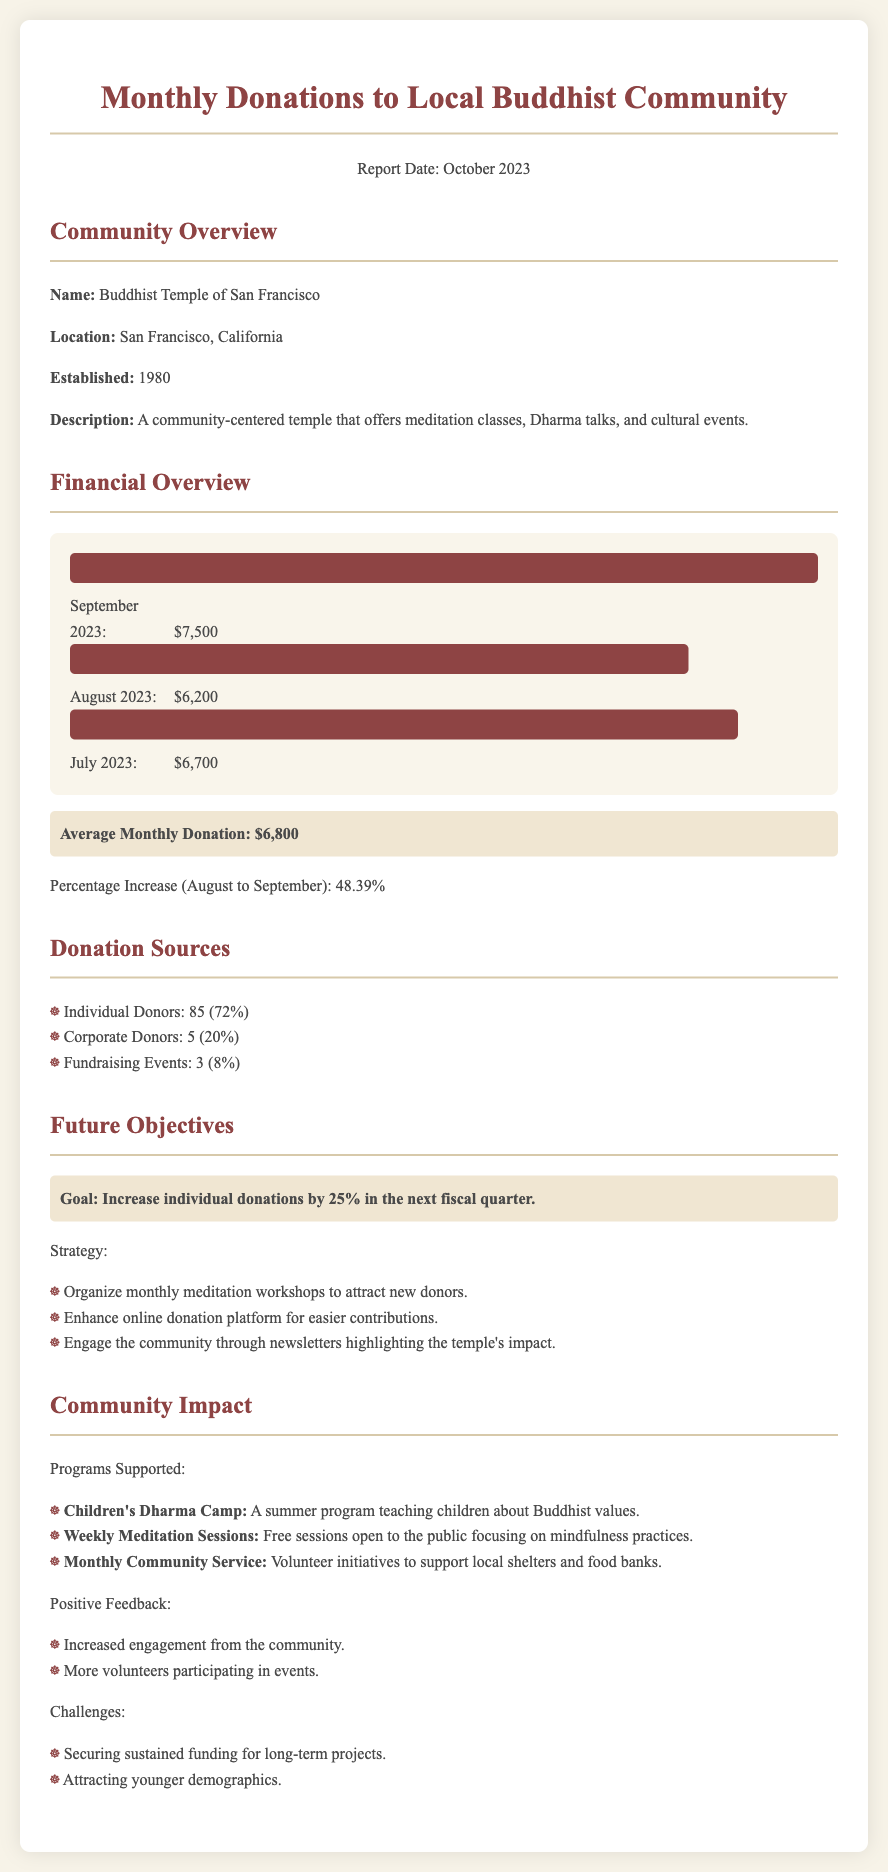What is the name of the community? The name of the community is listed in the document as "Buddhist Temple of San Francisco."
Answer: Buddhist Temple of San Francisco What was the average monthly donation? The average monthly donation can be found in the Financial Overview section, which states it is $6,800.
Answer: $6,800 What percentage increase in donations was observed from August to September? The document specifies a percentage increase of 48.39% between these months.
Answer: 48.39% How many individual donors contributed? The number of individual donors is provided in the Donation Sources section as 85.
Answer: 85 What is the goal for individual donations in the next fiscal quarter? The goal mentioned in the Future Objectives section is to increase individual donations by 25%.
Answer: 25% What type of program does the Children's Dharma Camp focus on? The document describes the Children's Dharma Camp as teaching children about Buddhist values.
Answer: Buddhist values What challenge is mentioned regarding community engagement? One of the challenges is attracting younger demographics as noted in the Community Impact section.
Answer: Attracting younger demographics What strategy is planned to enhance donations? The document mentions enhancing the online donation platform as a strategy.
Answer: Enhance online donation platform 